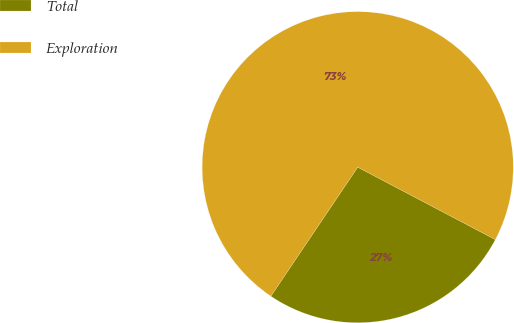Convert chart. <chart><loc_0><loc_0><loc_500><loc_500><pie_chart><fcel>Total<fcel>Exploration<nl><fcel>26.72%<fcel>73.28%<nl></chart> 